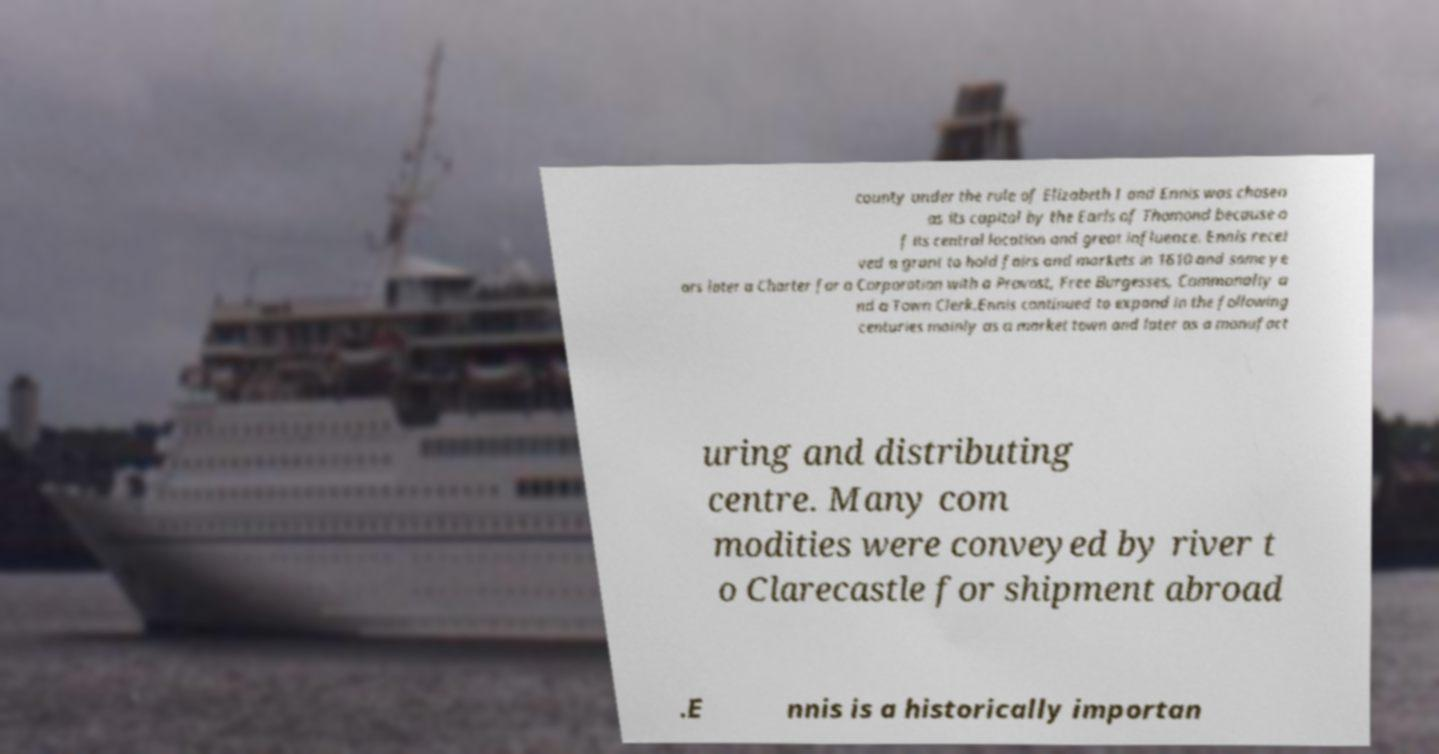What messages or text are displayed in this image? I need them in a readable, typed format. county under the rule of Elizabeth I and Ennis was chosen as its capital by the Earls of Thomond because o f its central location and great influence. Ennis recei ved a grant to hold fairs and markets in 1610 and some ye ars later a Charter for a Corporation with a Provost, Free Burgesses, Commonalty a nd a Town Clerk.Ennis continued to expand in the following centuries mainly as a market town and later as a manufact uring and distributing centre. Many com modities were conveyed by river t o Clarecastle for shipment abroad .E nnis is a historically importan 